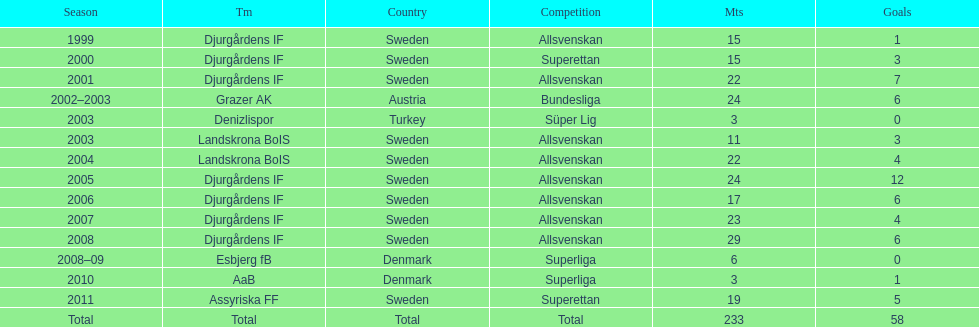What country is team djurgårdens if not from? Sweden. 